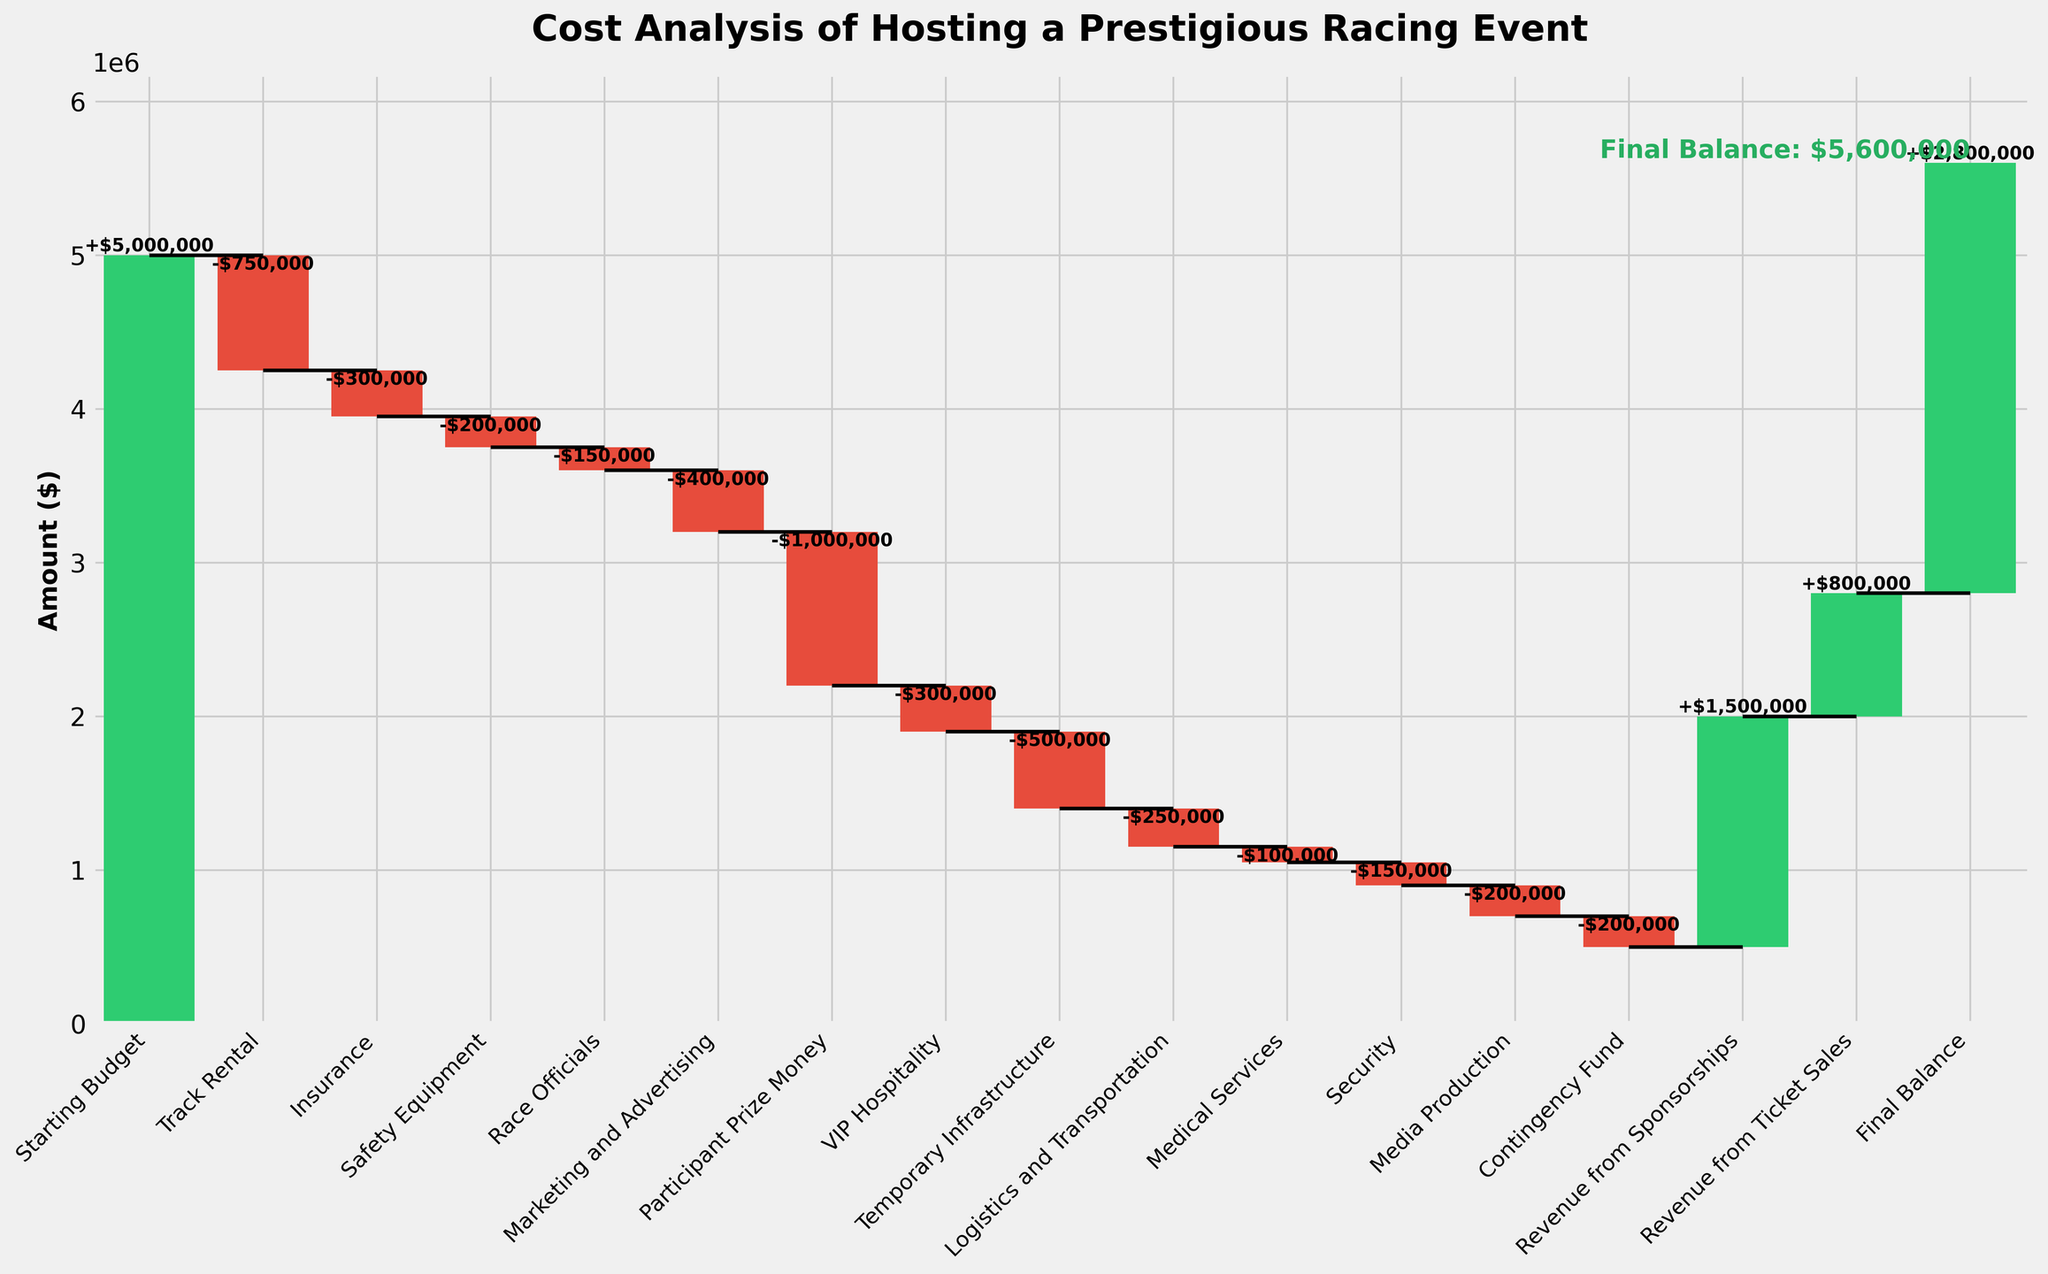What's the total starting budget for the event? The figure's title "Cost Analysis of Hosting a Prestigious Racing Event" and the first category labeled "Starting Budget" show this information.
Answer: $5,000,000 What does the cumulative total become after deducting the track rental cost? The track rental cost is $750,000, deducted from the starting budget of $5,000,000. Calculating $5,000,000 - $750,000 gives the intermediate balance.
Answer: $4,250,000 How much is allocated for participant prize money, and is it an expense or revenue? The bar labeled "Participant Prize Money" indicates its value is $1,000,000, and since it is a negative amount, it is an expense.
Answer: $1,000,000; expense How does the final balance compare to the starting budget? The final balance is $2,800,000, while the starting budget is $5,000,000. The difference can be calculated as $5,000,000 - $2,800,000.
Answer: $2,200,000 less How much revenue comes from sponsorships and ticket sales combined? The revenue amounts for "Revenue from Sponsorships" ($1,500,000) and "Revenue from Ticket Sales" ($800,000) need to be combined.
Answer: $2,300,000 Which expense—VIP Hospitality or Marketing and Advertising—is higher, and by how much? The values for "VIP Hospitality" and "Marketing and Advertising" are $300,000 and $400,000 respectively. The comparison shows that marketing and advertising is higher.
Answer: Marketing and Advertising by $100,000 What cumulative balance is left after deducting all expenses but before adding any revenue? Sum all expenses: Track Rental ($750,000), Insurance ($300,000), Safety Equipment ($200,000), Race Officials ($150,000), Marketing and Advertising ($400,000), Participant Prize Money ($1,000,000), VIP Hospitality ($300,000), Temporary Infrastructure ($500,000), Logistics and Transportation ($250,000), Medical Services ($100,000), Security ($150,000), Media Production ($200,000), Contingency Fund ($200,000). Starting with $5,000,000, subtract these to find the remaining balance before revenue.
Answer: $500,000 What amount does the contingency fund hold and is it positive or negative? The contingency fund value is labeled as $200,000 in the chart, and since it is a negative amount, it represents an expense.
Answer: $200,000; negative If only revenue from ticket sales is considered, will the event still yield a positive balance? The intermediate cumulative balance before any revenue starts at $500,000. Adding revenue from ticket sales ($800,000) results in $1,300,000. This is still positive.
Answer: Yes, $1,300,000 